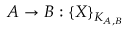<formula> <loc_0><loc_0><loc_500><loc_500>A \rightarrow B \colon \{ X \} _ { K _ { A , B } }</formula> 